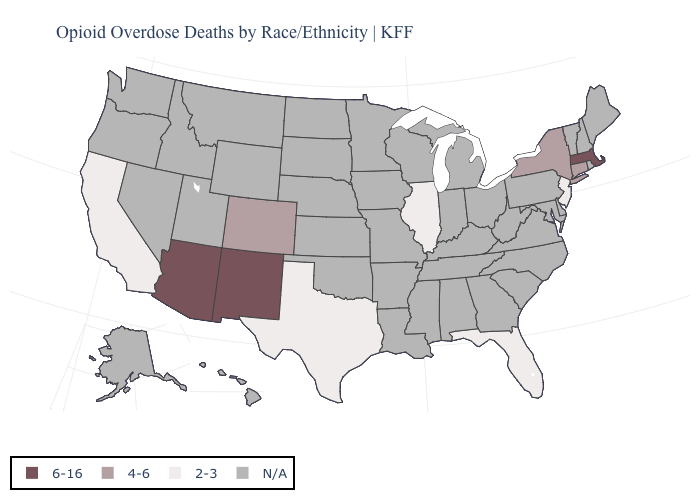Name the states that have a value in the range 2-3?
Write a very short answer. California, Florida, Illinois, New Jersey, Texas. Name the states that have a value in the range 2-3?
Quick response, please. California, Florida, Illinois, New Jersey, Texas. Name the states that have a value in the range 2-3?
Short answer required. California, Florida, Illinois, New Jersey, Texas. Is the legend a continuous bar?
Short answer required. No. Among the states that border New York , does Massachusetts have the highest value?
Give a very brief answer. Yes. What is the value of Kentucky?
Keep it brief. N/A. Name the states that have a value in the range 4-6?
Give a very brief answer. Colorado, Connecticut, New York. Name the states that have a value in the range 4-6?
Keep it brief. Colorado, Connecticut, New York. What is the highest value in the USA?
Keep it brief. 6-16. What is the lowest value in the USA?
Concise answer only. 2-3. 